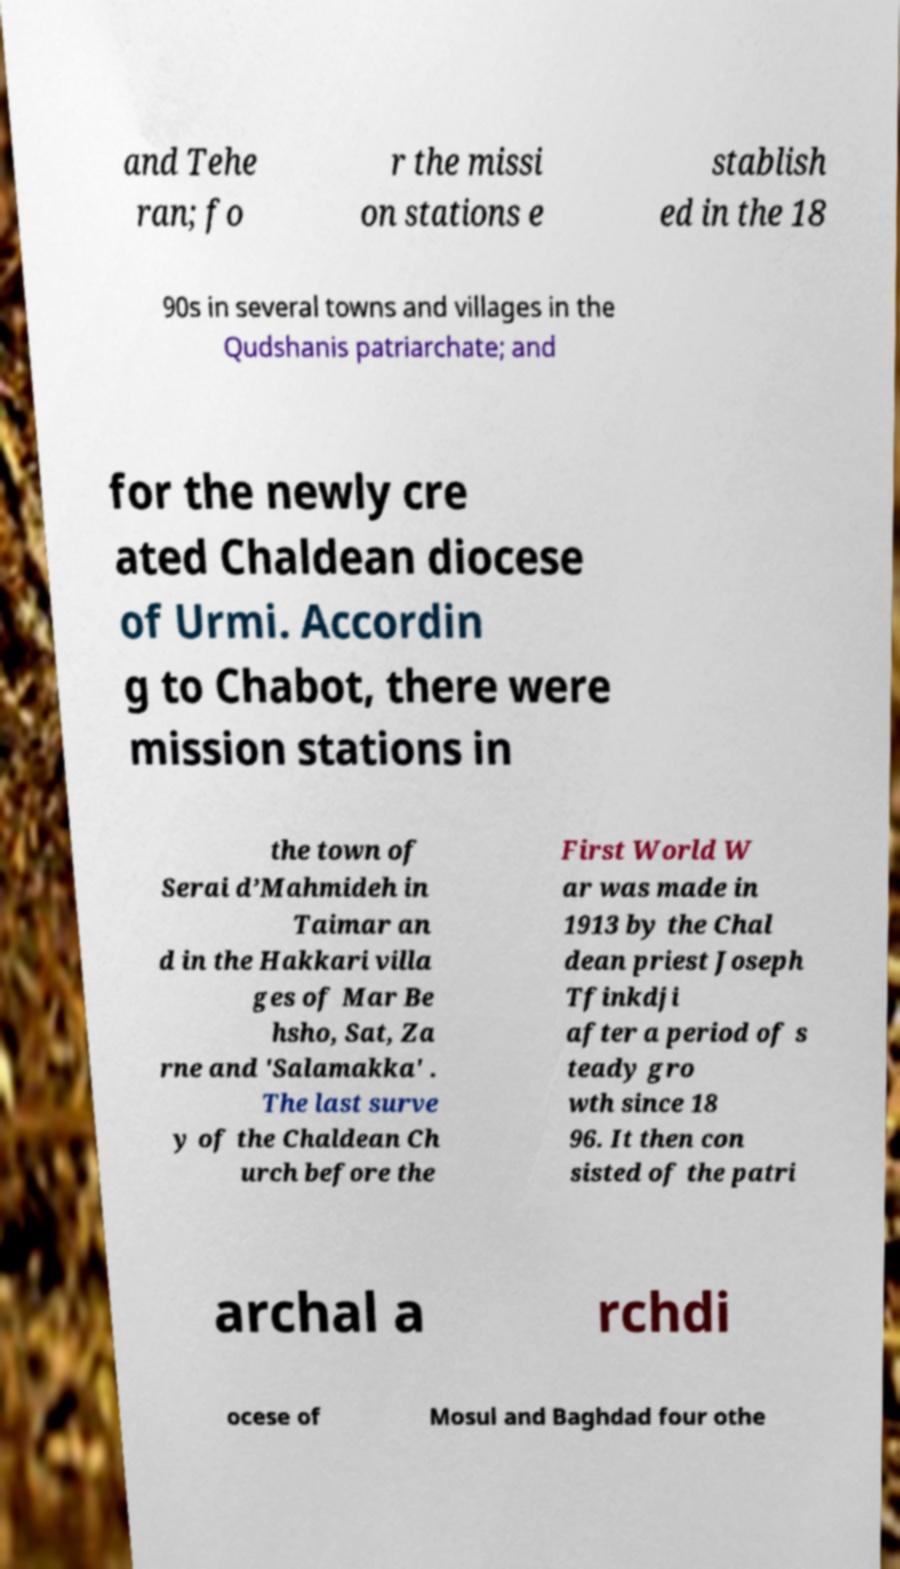Can you accurately transcribe the text from the provided image for me? and Tehe ran; fo r the missi on stations e stablish ed in the 18 90s in several towns and villages in the Qudshanis patriarchate; and for the newly cre ated Chaldean diocese of Urmi. Accordin g to Chabot, there were mission stations in the town of Serai d’Mahmideh in Taimar an d in the Hakkari villa ges of Mar Be hsho, Sat, Za rne and 'Salamakka' . The last surve y of the Chaldean Ch urch before the First World W ar was made in 1913 by the Chal dean priest Joseph Tfinkdji after a period of s teady gro wth since 18 96. It then con sisted of the patri archal a rchdi ocese of Mosul and Baghdad four othe 